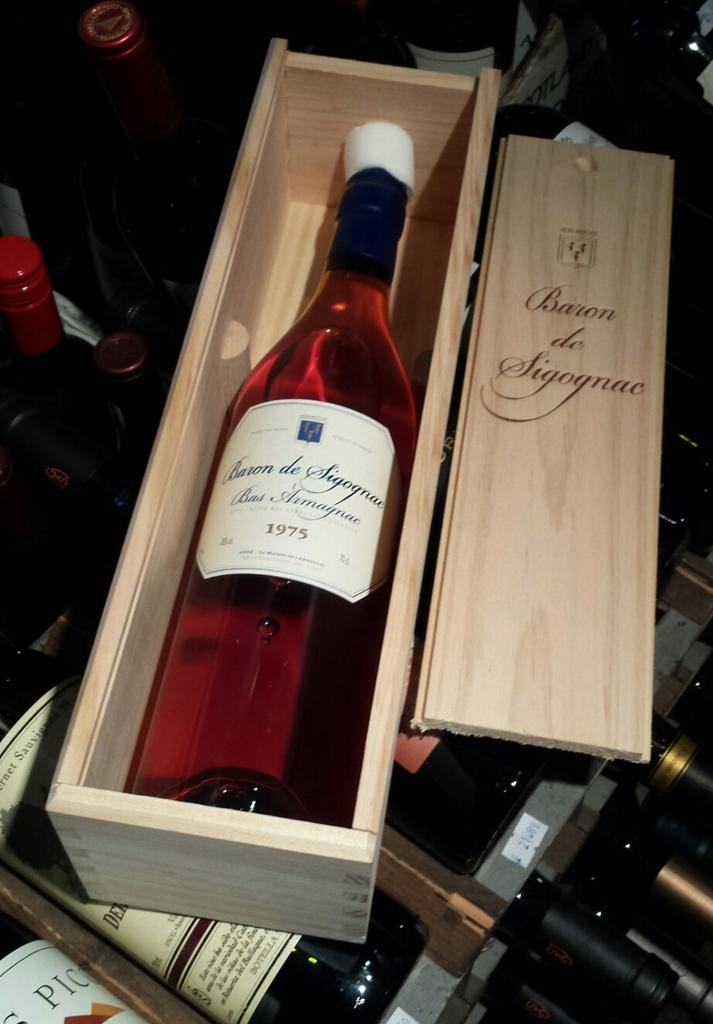<image>
Give a short and clear explanation of the subsequent image. A bottle of Baron de Sigognac is laying in a wooden box. 